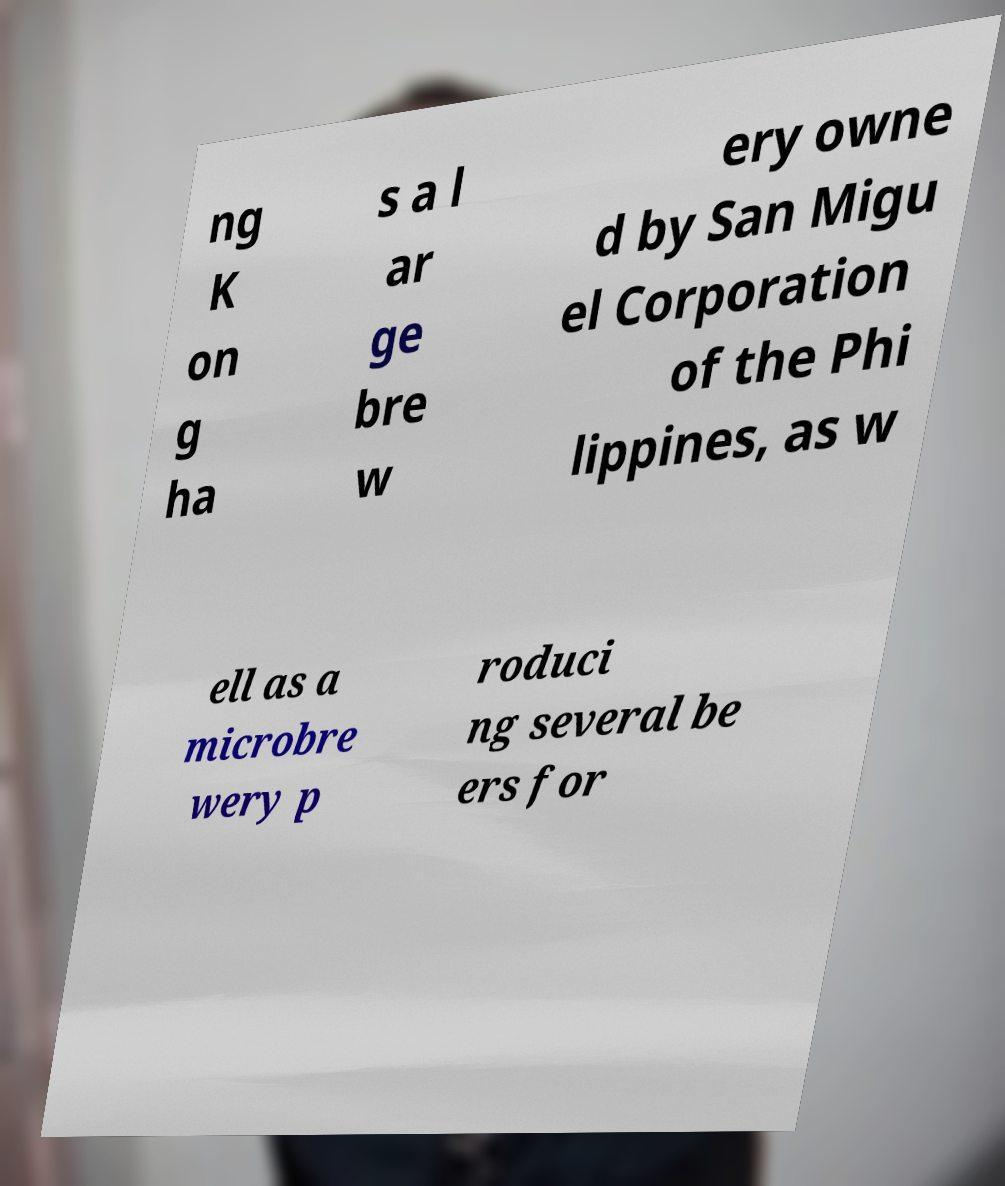For documentation purposes, I need the text within this image transcribed. Could you provide that? ng K on g ha s a l ar ge bre w ery owne d by San Migu el Corporation of the Phi lippines, as w ell as a microbre wery p roduci ng several be ers for 